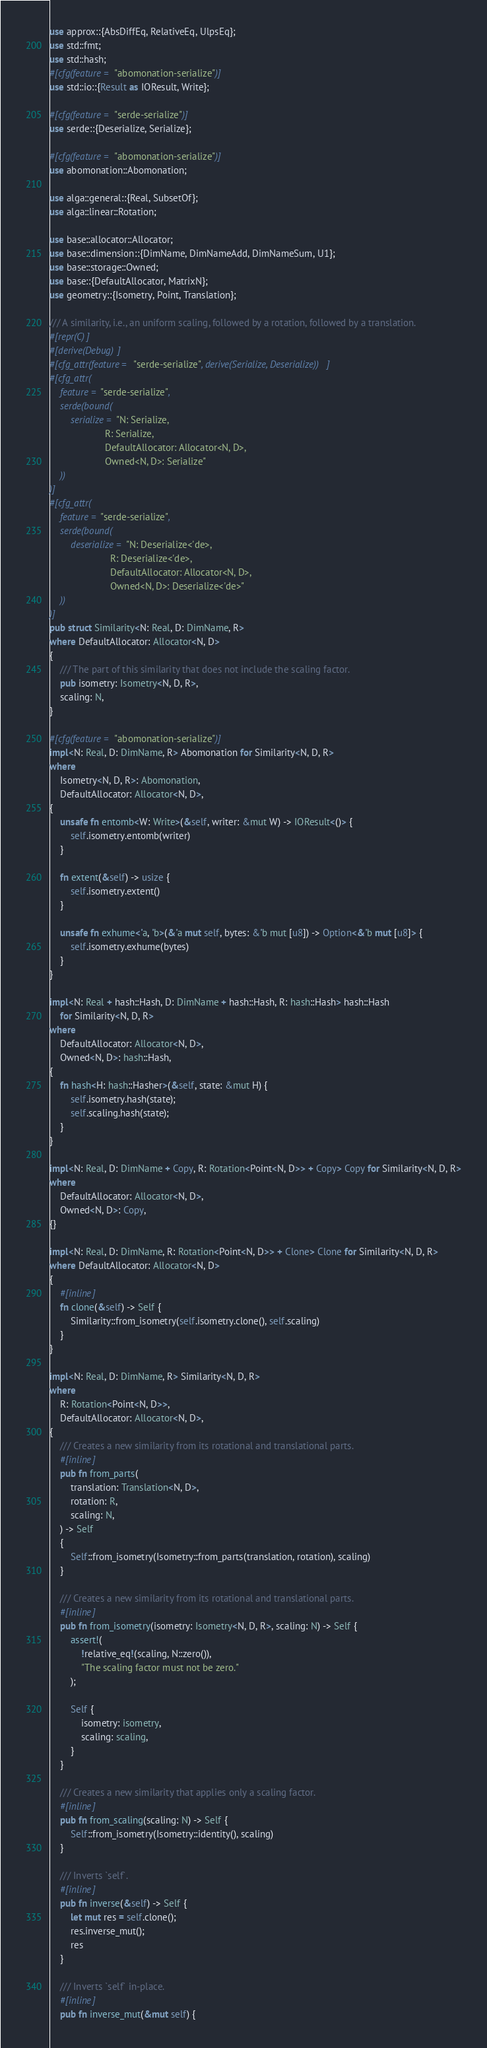<code> <loc_0><loc_0><loc_500><loc_500><_Rust_>use approx::{AbsDiffEq, RelativeEq, UlpsEq};
use std::fmt;
use std::hash;
#[cfg(feature = "abomonation-serialize")]
use std::io::{Result as IOResult, Write};

#[cfg(feature = "serde-serialize")]
use serde::{Deserialize, Serialize};

#[cfg(feature = "abomonation-serialize")]
use abomonation::Abomonation;

use alga::general::{Real, SubsetOf};
use alga::linear::Rotation;

use base::allocator::Allocator;
use base::dimension::{DimName, DimNameAdd, DimNameSum, U1};
use base::storage::Owned;
use base::{DefaultAllocator, MatrixN};
use geometry::{Isometry, Point, Translation};

/// A similarity, i.e., an uniform scaling, followed by a rotation, followed by a translation.
#[repr(C)]
#[derive(Debug)]
#[cfg_attr(feature = "serde-serialize", derive(Serialize, Deserialize))]
#[cfg_attr(
    feature = "serde-serialize",
    serde(bound(
        serialize = "N: Serialize,
                     R: Serialize,
                     DefaultAllocator: Allocator<N, D>,
                     Owned<N, D>: Serialize"
    ))
)]
#[cfg_attr(
    feature = "serde-serialize",
    serde(bound(
        deserialize = "N: Deserialize<'de>,
                       R: Deserialize<'de>,
                       DefaultAllocator: Allocator<N, D>,
                       Owned<N, D>: Deserialize<'de>"
    ))
)]
pub struct Similarity<N: Real, D: DimName, R>
where DefaultAllocator: Allocator<N, D>
{
    /// The part of this similarity that does not include the scaling factor.
    pub isometry: Isometry<N, D, R>,
    scaling: N,
}

#[cfg(feature = "abomonation-serialize")]
impl<N: Real, D: DimName, R> Abomonation for Similarity<N, D, R>
where
    Isometry<N, D, R>: Abomonation,
    DefaultAllocator: Allocator<N, D>,
{
    unsafe fn entomb<W: Write>(&self, writer: &mut W) -> IOResult<()> {
        self.isometry.entomb(writer)
    }

    fn extent(&self) -> usize {
        self.isometry.extent()
    }

    unsafe fn exhume<'a, 'b>(&'a mut self, bytes: &'b mut [u8]) -> Option<&'b mut [u8]> {
        self.isometry.exhume(bytes)
    }
}

impl<N: Real + hash::Hash, D: DimName + hash::Hash, R: hash::Hash> hash::Hash
    for Similarity<N, D, R>
where
    DefaultAllocator: Allocator<N, D>,
    Owned<N, D>: hash::Hash,
{
    fn hash<H: hash::Hasher>(&self, state: &mut H) {
        self.isometry.hash(state);
        self.scaling.hash(state);
    }
}

impl<N: Real, D: DimName + Copy, R: Rotation<Point<N, D>> + Copy> Copy for Similarity<N, D, R>
where
    DefaultAllocator: Allocator<N, D>,
    Owned<N, D>: Copy,
{}

impl<N: Real, D: DimName, R: Rotation<Point<N, D>> + Clone> Clone for Similarity<N, D, R>
where DefaultAllocator: Allocator<N, D>
{
    #[inline]
    fn clone(&self) -> Self {
        Similarity::from_isometry(self.isometry.clone(), self.scaling)
    }
}

impl<N: Real, D: DimName, R> Similarity<N, D, R>
where
    R: Rotation<Point<N, D>>,
    DefaultAllocator: Allocator<N, D>,
{
    /// Creates a new similarity from its rotational and translational parts.
    #[inline]
    pub fn from_parts(
        translation: Translation<N, D>,
        rotation: R,
        scaling: N,
    ) -> Self
    {
        Self::from_isometry(Isometry::from_parts(translation, rotation), scaling)
    }

    /// Creates a new similarity from its rotational and translational parts.
    #[inline]
    pub fn from_isometry(isometry: Isometry<N, D, R>, scaling: N) -> Self {
        assert!(
            !relative_eq!(scaling, N::zero()),
            "The scaling factor must not be zero."
        );

        Self {
            isometry: isometry,
            scaling: scaling,
        }
    }

    /// Creates a new similarity that applies only a scaling factor.
    #[inline]
    pub fn from_scaling(scaling: N) -> Self {
        Self::from_isometry(Isometry::identity(), scaling)
    }

    /// Inverts `self`.
    #[inline]
    pub fn inverse(&self) -> Self {
        let mut res = self.clone();
        res.inverse_mut();
        res
    }

    /// Inverts `self` in-place.
    #[inline]
    pub fn inverse_mut(&mut self) {</code> 